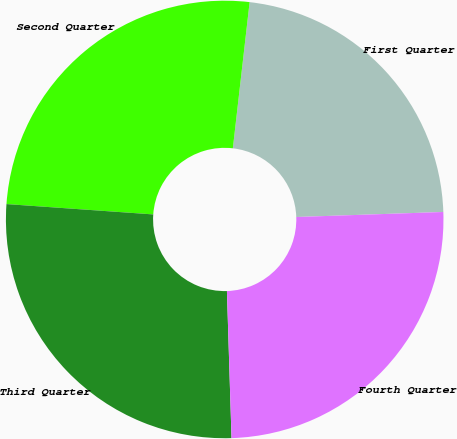Convert chart. <chart><loc_0><loc_0><loc_500><loc_500><pie_chart><fcel>First Quarter<fcel>Second Quarter<fcel>Third Quarter<fcel>Fourth Quarter<nl><fcel>22.64%<fcel>25.7%<fcel>26.62%<fcel>25.05%<nl></chart> 